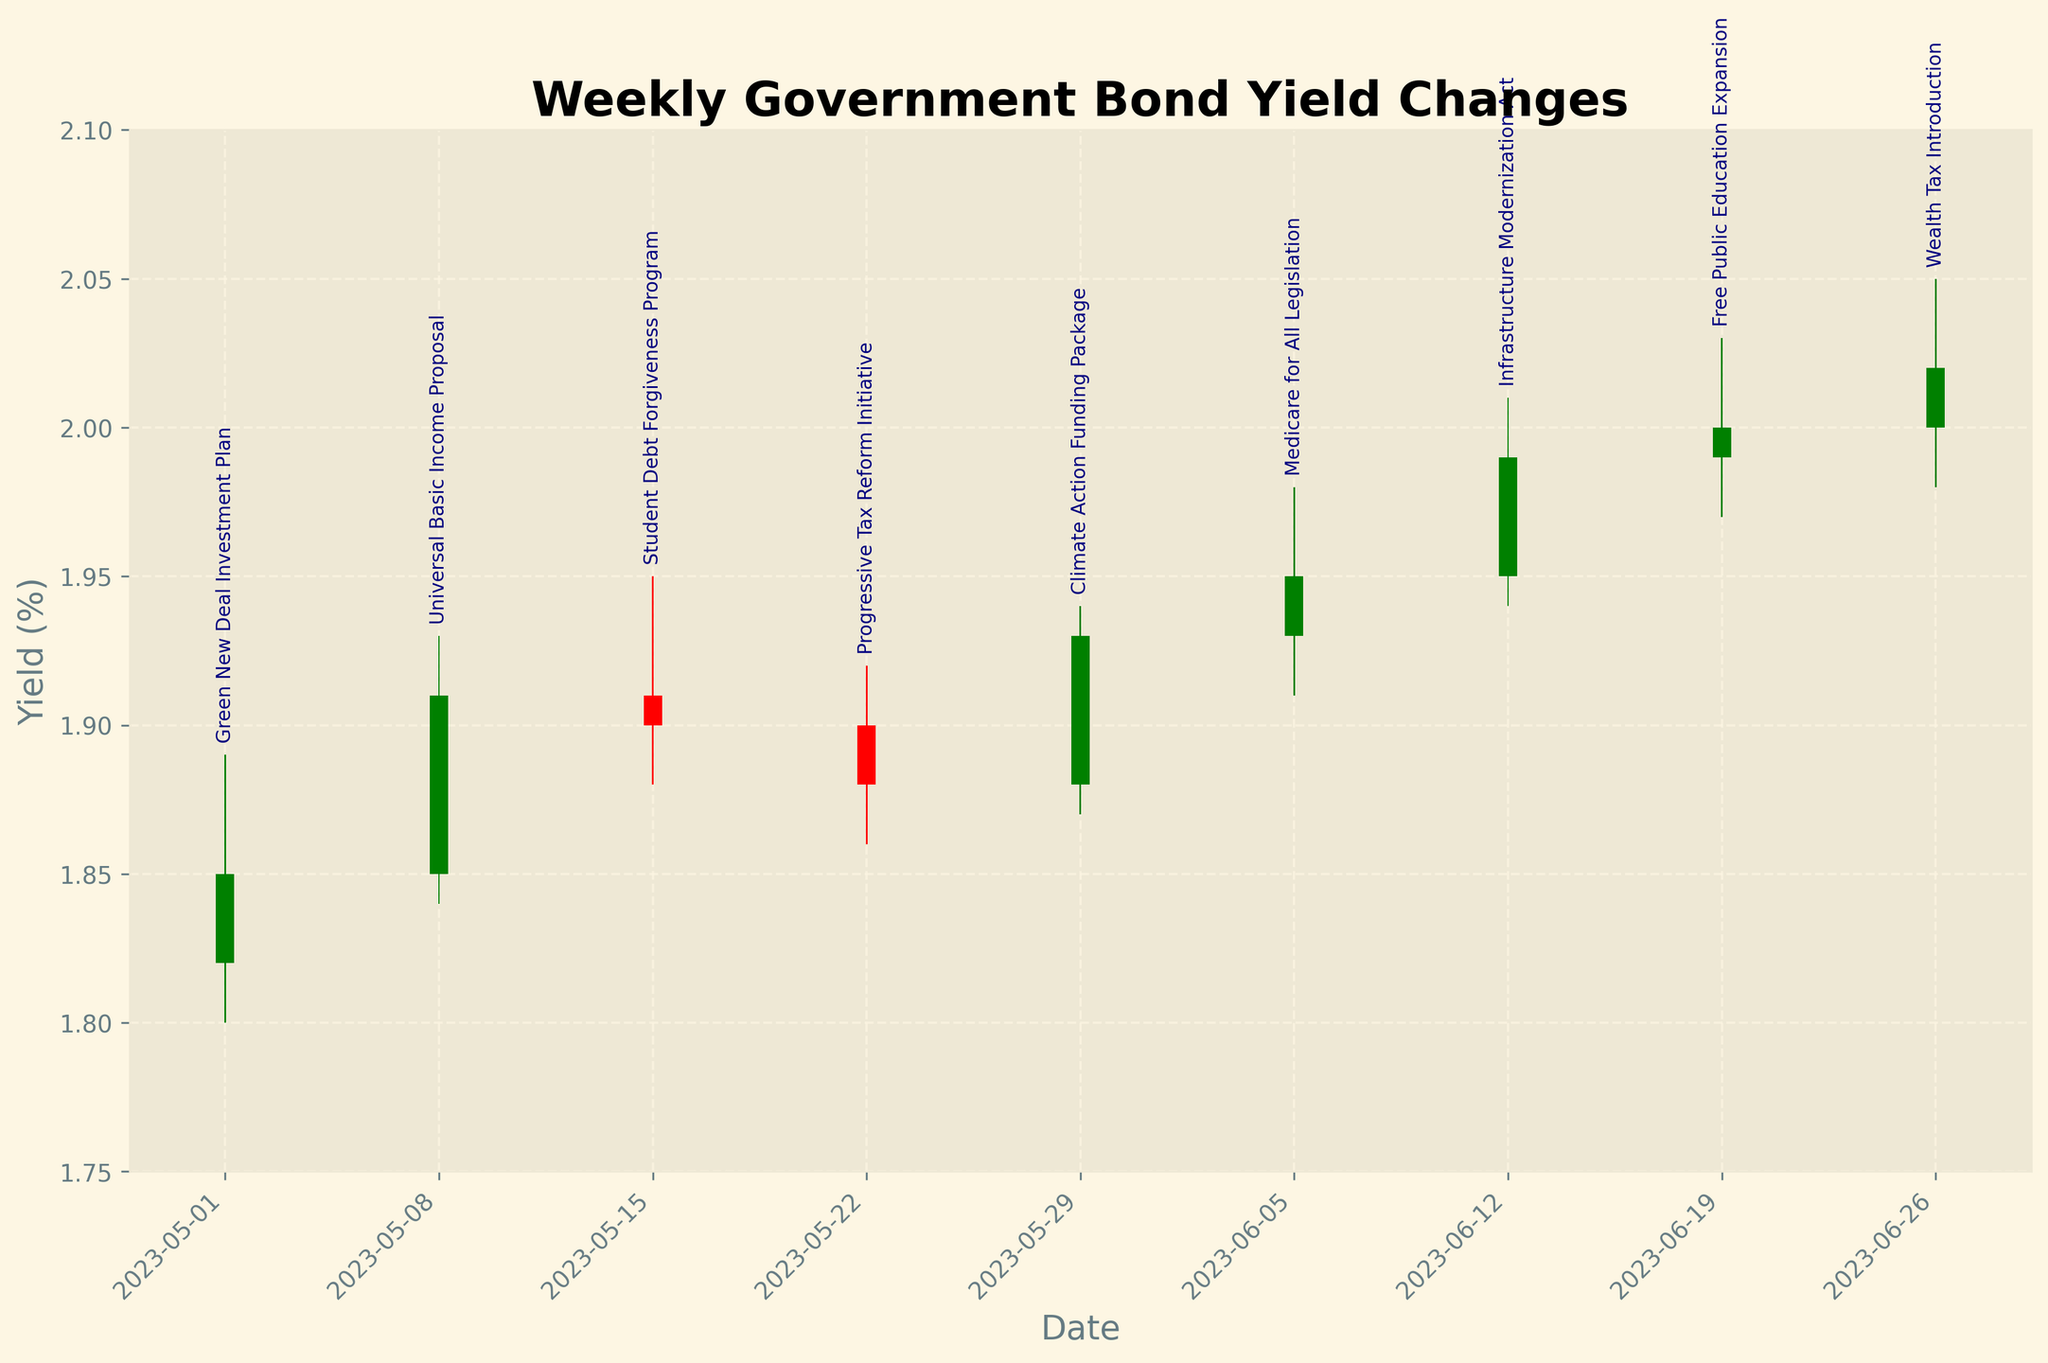What is the title of the chart? The title of the chart is usually displayed at the top of the figure. Here, it is labeled as "Weekly Government Bond Yield Changes".
Answer: Weekly Government Bond Yield Changes How many policy announcements are annotated in the chart? Each bar on the chart corresponds to a policy announcement, and there are 9 bars. Therefore, there are 9 policy announcements annotated in the chart.
Answer: 9 Which policy announcement is associated with the highest yield? By examining the highest values on the vertical axis and checking the annotations, the highest yield corresponds to the week of "Free Public Education Expansion" on 2023-06-19, reaching 2.03%.
Answer: Free Public Education Expansion Which weeks had a closing yield higher than the opening yield? Bars are colored green when the closing yield is higher than the opening yield. By inspecting these green bars, we see that the weeks of 2023-05-01, 2023-05-08, 2023-05-29, 2023-06-05, 2023-06-19, and 2023-06-26 had closing yields higher than the opening yields.
Answer: 2023-05-01, 2023-05-08, 2023-05-29, 2023-06-05, 2023-06-19, 2023-06-26 What was the opening yield on 2023-06-12? The chart shows yields along the vertical axis, and for 2023-06-12, the bar starts at the opening yield value, which is 1.95%.
Answer: 1.95% What is the average closing yield for the given data? To find the average closing yield, sum up all the closing yields and divide by the number of weeks. The closing yields are 1.85, 1.91, 1.90, 1.88, 1.93, 1.95, 1.99, 2.00, and 2.02. Their sum is 17.43, and the average is 17.43 / 9.
Answer: 1.937 Which policy announcement caused the largest drop in yield from open to close within the week? The largest yield drop can be seen in the bar with the largest red body, indicating a downward trend. The week of "Progressive Tax Reform Initiative" on 2023-05-22 had the largest drop, from 1.90 to 1.88.
Answer: Progressive Tax Reform Initiative How did the yield change on 2023-05-29 compared to the previous week? On 2023-05-29, the yield rose from the opening yield of 1.88 to a closing of 1.93. The previous week on 2023-05-22 had a closing yield of 1.88, so the yield increased by 0.05% (1.93 - 1.88).
Answer: Increased by 0.05% Which policy announcements did not cause any net change in yield over the week, judging by the opening and closing values? Checking for bars where the opening and closing yields are the same (no change in the body of the bar), there are no such instances. All weeks show a change from open to close.
Answer: None 